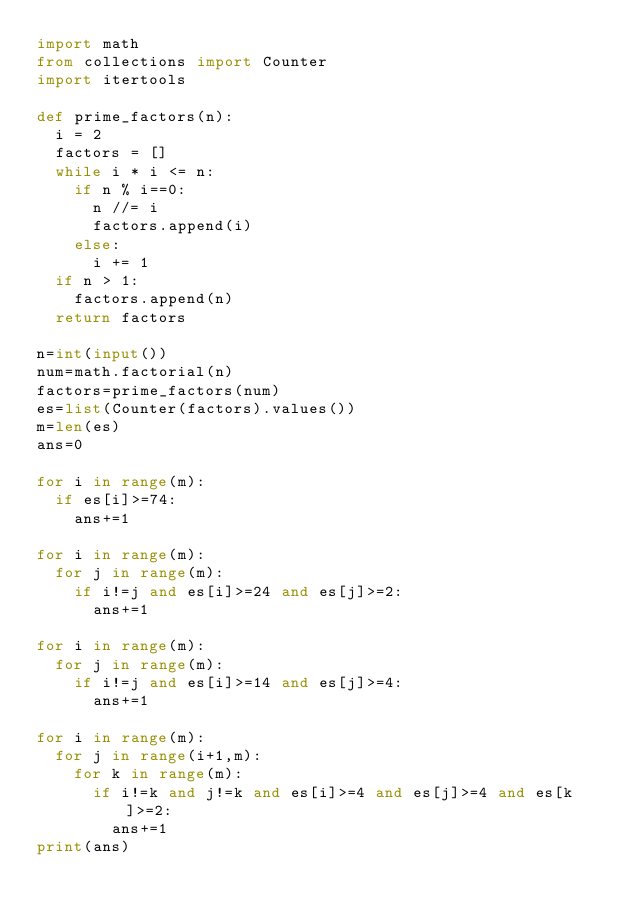Convert code to text. <code><loc_0><loc_0><loc_500><loc_500><_Python_>import math
from collections import Counter
import itertools

def prime_factors(n):
  i = 2
  factors = []
  while i * i <= n:
    if n % i==0:
      n //= i
      factors.append(i)
    else:
      i += 1
  if n > 1:
    factors.append(n)
  return factors

n=int(input())
num=math.factorial(n)
factors=prime_factors(num)
es=list(Counter(factors).values())
m=len(es)
ans=0

for i in range(m):
  if es[i]>=74:
    ans+=1

for i in range(m):
  for j in range(m):
    if i!=j and es[i]>=24 and es[j]>=2:
      ans+=1

for i in range(m):
  for j in range(m):
    if i!=j and es[i]>=14 and es[j]>=4:
      ans+=1

for i in range(m):
  for j in range(i+1,m):
    for k in range(m):
      if i!=k and j!=k and es[i]>=4 and es[j]>=4 and es[k]>=2:
        ans+=1
print(ans)
</code> 